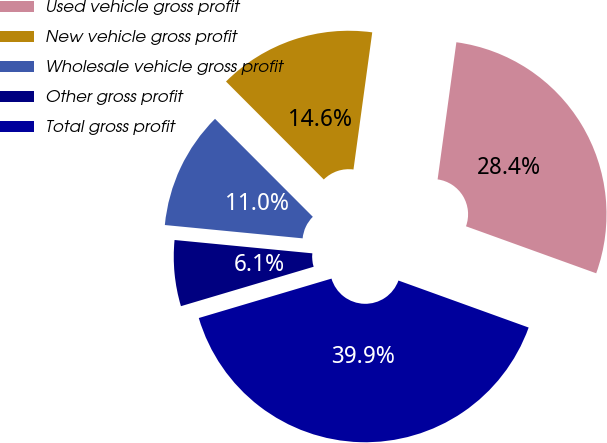<chart> <loc_0><loc_0><loc_500><loc_500><pie_chart><fcel>Used vehicle gross profit<fcel>New vehicle gross profit<fcel>Wholesale vehicle gross profit<fcel>Other gross profit<fcel>Total gross profit<nl><fcel>28.35%<fcel>14.65%<fcel>10.98%<fcel>6.13%<fcel>39.89%<nl></chart> 